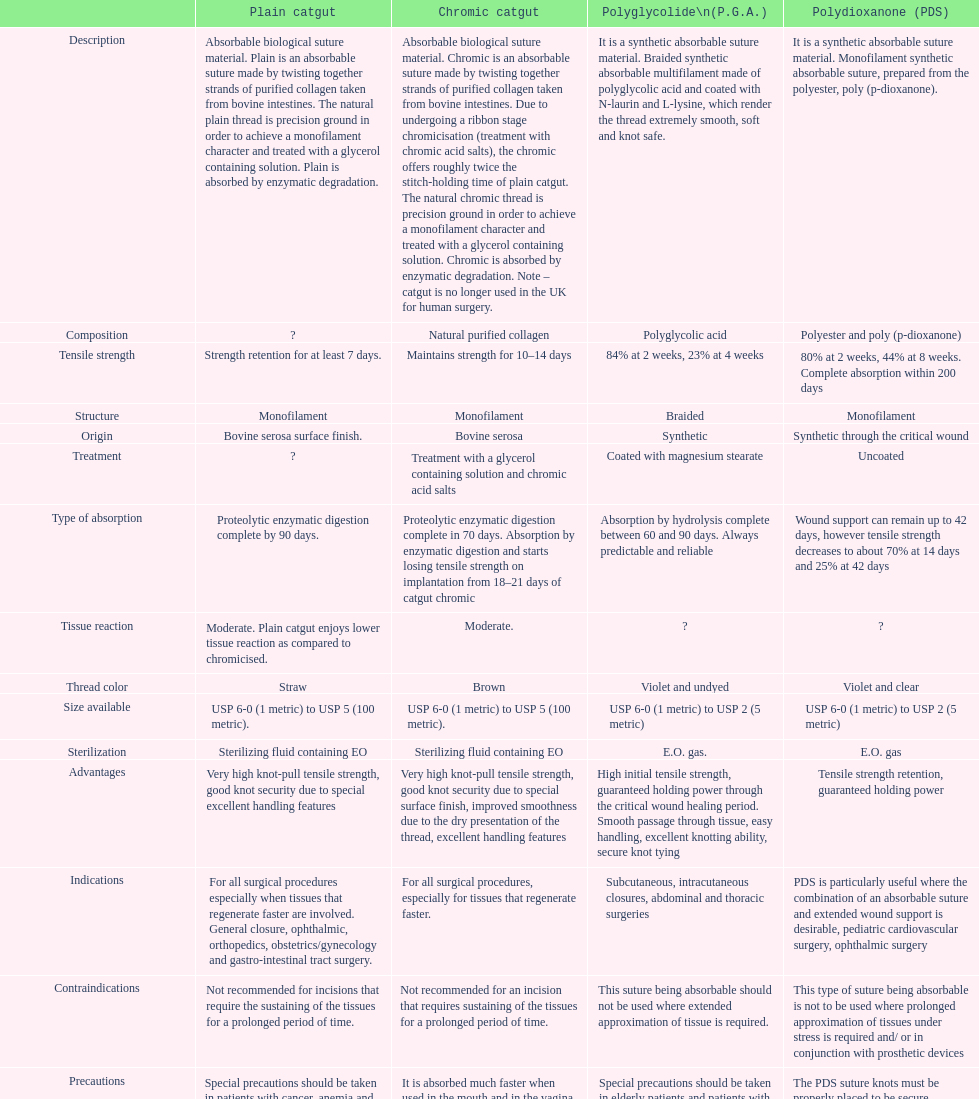What type of suture is not to be used in conjunction with prosthetic devices? Polydioxanone (PDS). 